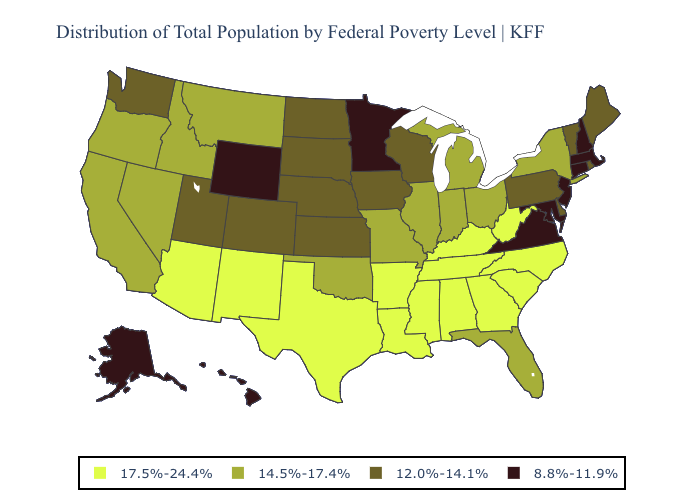Name the states that have a value in the range 17.5%-24.4%?
Short answer required. Alabama, Arizona, Arkansas, Georgia, Kentucky, Louisiana, Mississippi, New Mexico, North Carolina, South Carolina, Tennessee, Texas, West Virginia. Name the states that have a value in the range 17.5%-24.4%?
Quick response, please. Alabama, Arizona, Arkansas, Georgia, Kentucky, Louisiana, Mississippi, New Mexico, North Carolina, South Carolina, Tennessee, Texas, West Virginia. What is the value of Iowa?
Short answer required. 12.0%-14.1%. What is the value of Wisconsin?
Concise answer only. 12.0%-14.1%. Does Minnesota have the lowest value in the MidWest?
Concise answer only. Yes. Does Michigan have the lowest value in the MidWest?
Give a very brief answer. No. Name the states that have a value in the range 17.5%-24.4%?
Give a very brief answer. Alabama, Arizona, Arkansas, Georgia, Kentucky, Louisiana, Mississippi, New Mexico, North Carolina, South Carolina, Tennessee, Texas, West Virginia. Which states have the lowest value in the West?
Quick response, please. Alaska, Hawaii, Wyoming. Name the states that have a value in the range 14.5%-17.4%?
Quick response, please. California, Florida, Idaho, Illinois, Indiana, Michigan, Missouri, Montana, Nevada, New York, Ohio, Oklahoma, Oregon. Does the first symbol in the legend represent the smallest category?
Quick response, please. No. Does New York have the lowest value in the USA?
Give a very brief answer. No. Does Ohio have the highest value in the MidWest?
Answer briefly. Yes. Among the states that border Texas , does Oklahoma have the highest value?
Be succinct. No. What is the lowest value in the MidWest?
Short answer required. 8.8%-11.9%. Name the states that have a value in the range 14.5%-17.4%?
Give a very brief answer. California, Florida, Idaho, Illinois, Indiana, Michigan, Missouri, Montana, Nevada, New York, Ohio, Oklahoma, Oregon. 